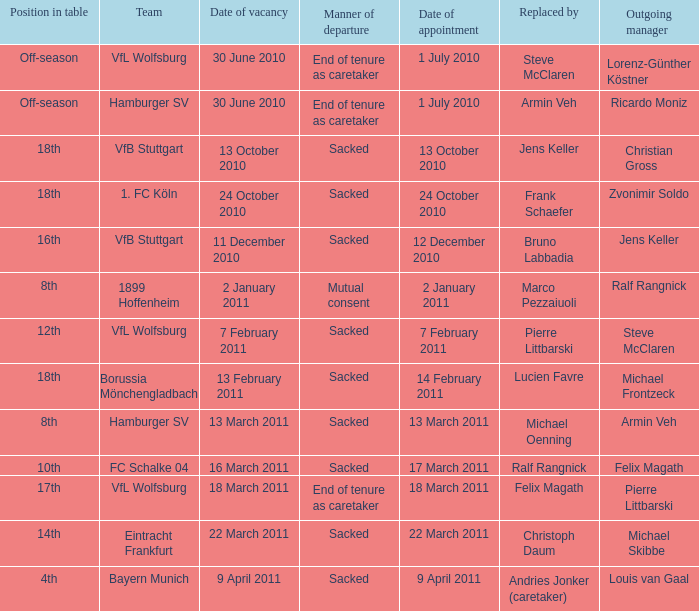When 1. fc köln is the team what is the date of appointment? 24 October 2010. 